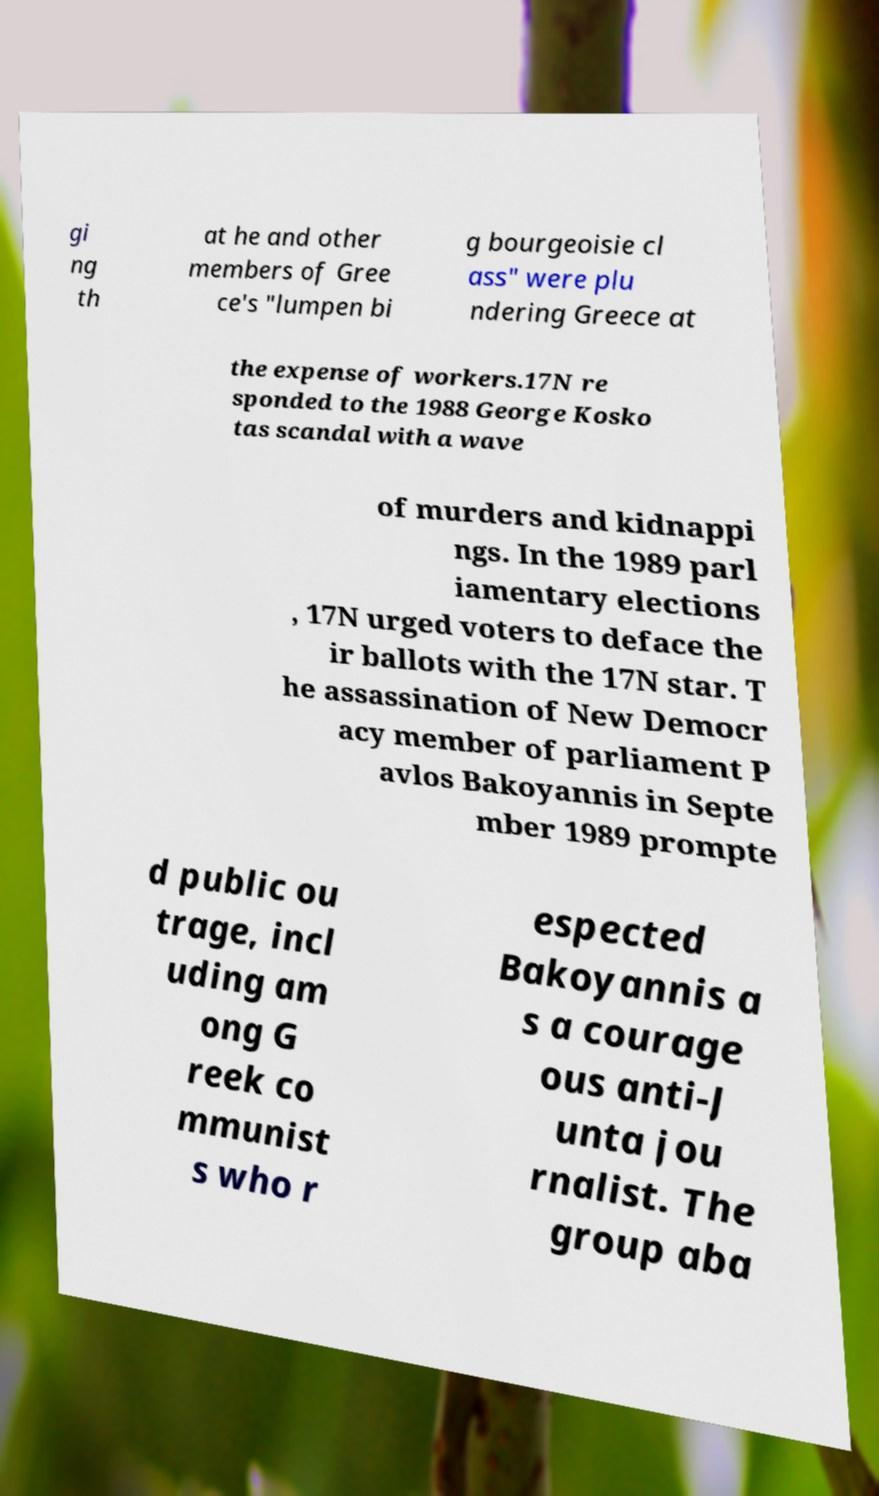Can you accurately transcribe the text from the provided image for me? gi ng th at he and other members of Gree ce's "lumpen bi g bourgeoisie cl ass" were plu ndering Greece at the expense of workers.17N re sponded to the 1988 George Kosko tas scandal with a wave of murders and kidnappi ngs. In the 1989 parl iamentary elections , 17N urged voters to deface the ir ballots with the 17N star. T he assassination of New Democr acy member of parliament P avlos Bakoyannis in Septe mber 1989 prompte d public ou trage, incl uding am ong G reek co mmunist s who r espected Bakoyannis a s a courage ous anti-J unta jou rnalist. The group aba 